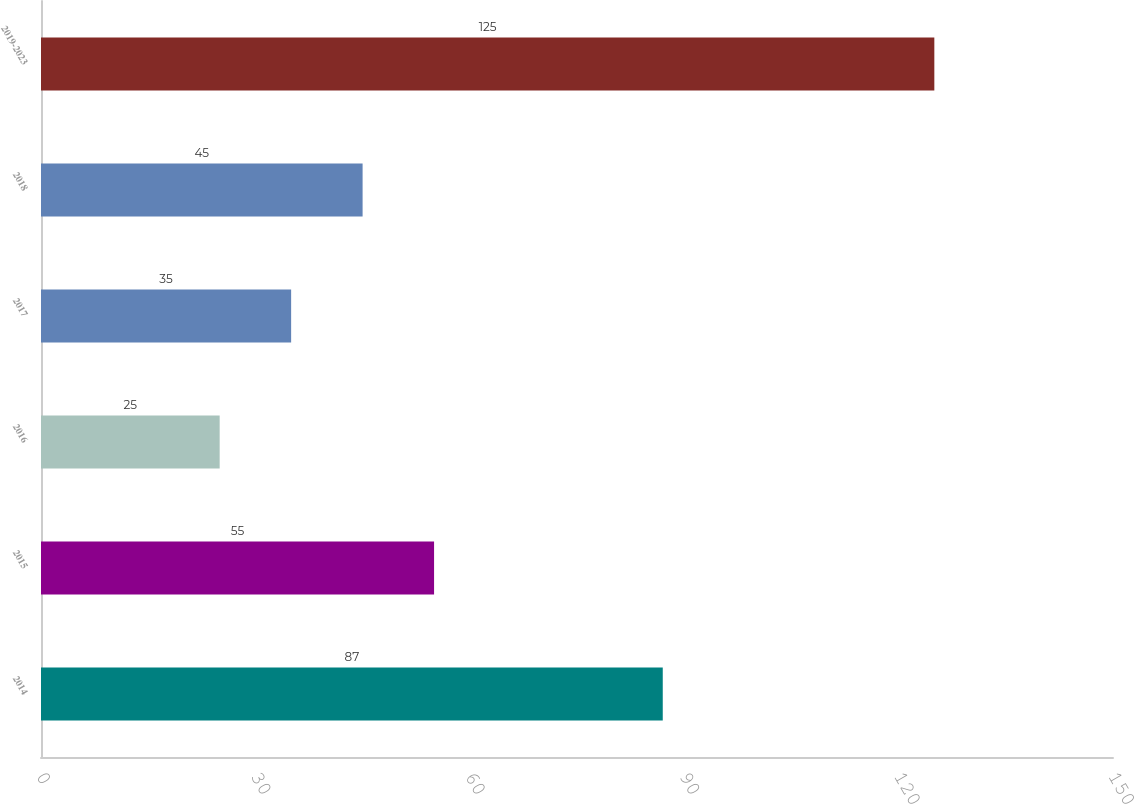Convert chart. <chart><loc_0><loc_0><loc_500><loc_500><bar_chart><fcel>2014<fcel>2015<fcel>2016<fcel>2017<fcel>2018<fcel>2019-2023<nl><fcel>87<fcel>55<fcel>25<fcel>35<fcel>45<fcel>125<nl></chart> 